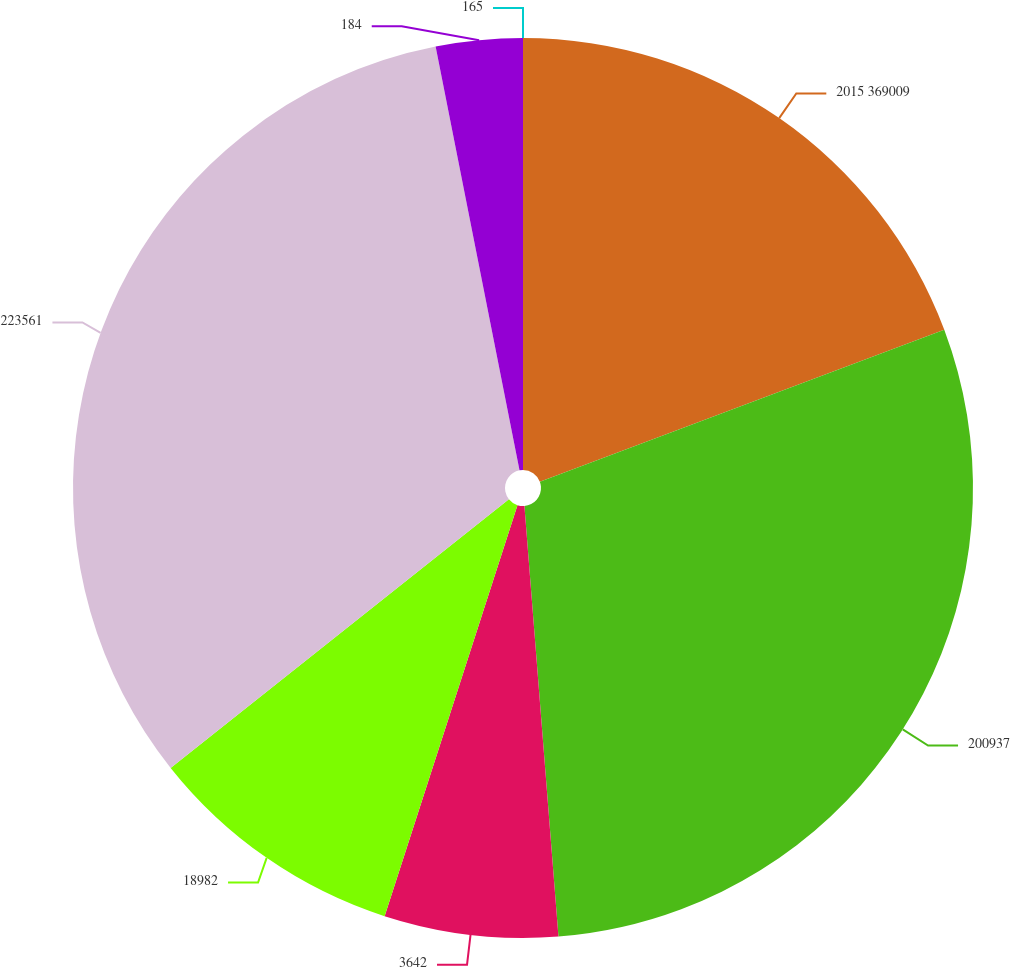Convert chart to OTSL. <chart><loc_0><loc_0><loc_500><loc_500><pie_chart><fcel>2015 369009<fcel>200937<fcel>3642<fcel>18982<fcel>223561<fcel>184<fcel>165<nl><fcel>19.28%<fcel>29.46%<fcel>6.23%<fcel>9.34%<fcel>32.57%<fcel>3.11%<fcel>0.0%<nl></chart> 